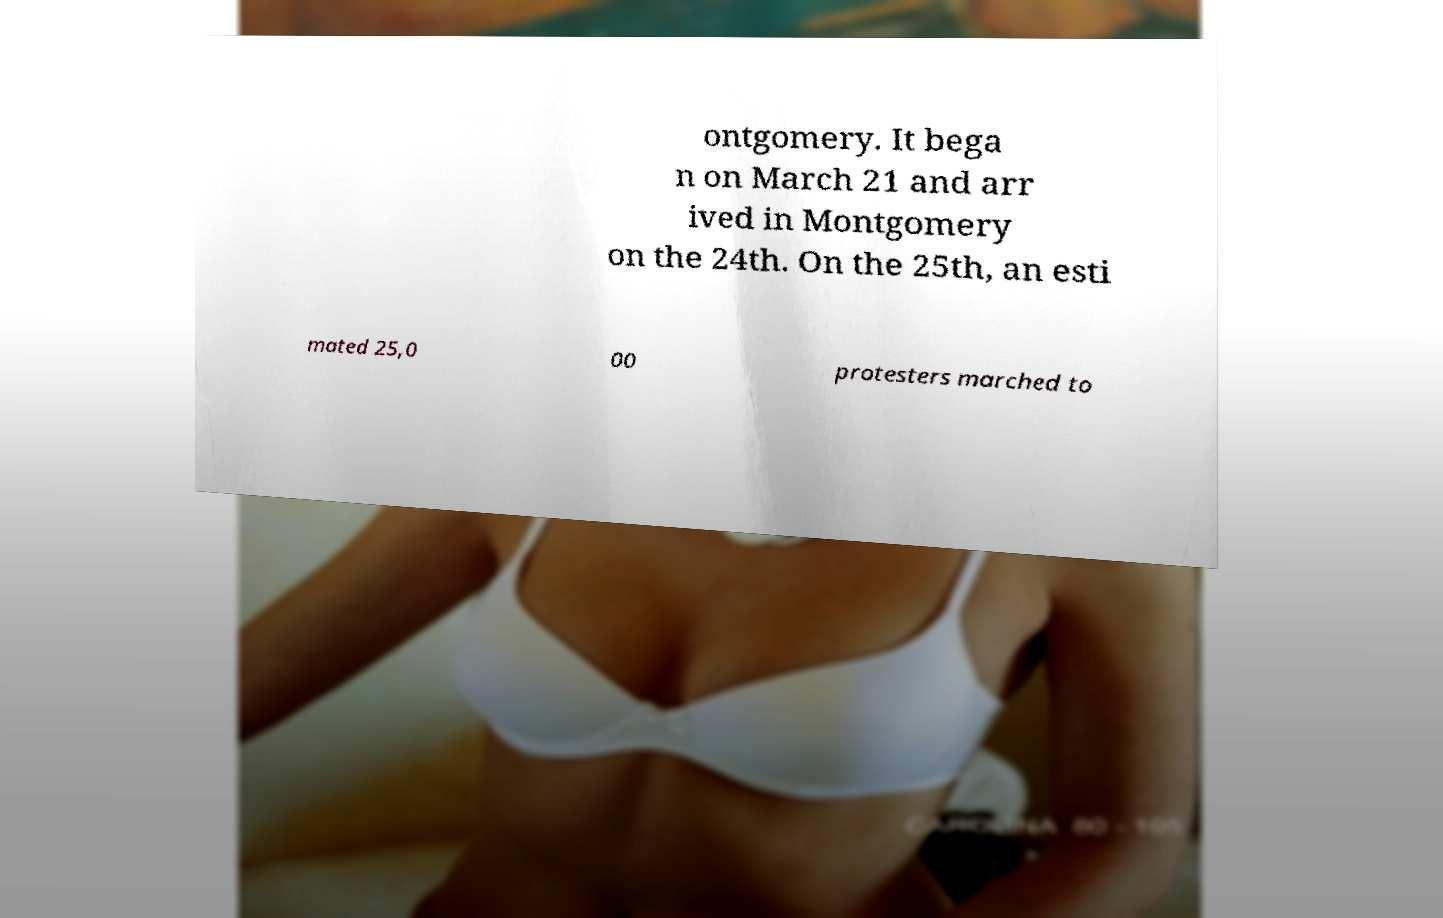There's text embedded in this image that I need extracted. Can you transcribe it verbatim? ontgomery. It bega n on March 21 and arr ived in Montgomery on the 24th. On the 25th, an esti mated 25,0 00 protesters marched to 